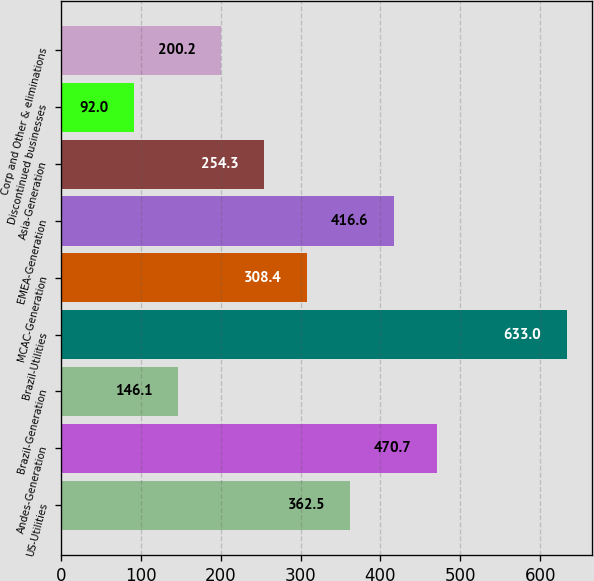<chart> <loc_0><loc_0><loc_500><loc_500><bar_chart><fcel>US-Utilities<fcel>Andes-Generation<fcel>Brazil-Generation<fcel>Brazil-Utilities<fcel>MCAC-Generation<fcel>EMEA-Generation<fcel>Asia-Generation<fcel>Discontinued businesses<fcel>Corp and Other & eliminations<nl><fcel>362.5<fcel>470.7<fcel>146.1<fcel>633<fcel>308.4<fcel>416.6<fcel>254.3<fcel>92<fcel>200.2<nl></chart> 